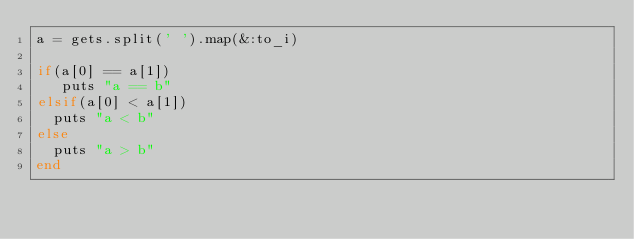Convert code to text. <code><loc_0><loc_0><loc_500><loc_500><_Ruby_>a = gets.split(' ').map(&:to_i)

if(a[0] == a[1])
   puts "a == b"
elsif(a[0] < a[1])
  puts "a < b"
else
  puts "a > b"
end
</code> 